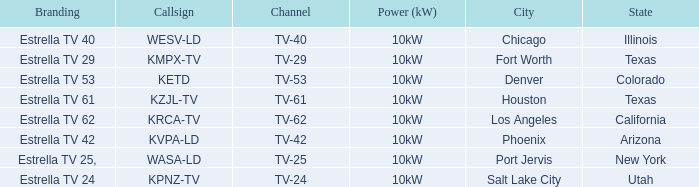List the power output for Phoenix.  10kW. 